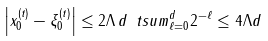Convert formula to latex. <formula><loc_0><loc_0><loc_500><loc_500>\left | x _ { 0 } ^ { ( t ) } - \xi _ { 0 } ^ { ( t ) } \right | & \leq 2 \Lambda \, d \, \ t s u m _ { \ell = 0 } ^ { d } 2 ^ { - \ell } \leq 4 \Lambda d</formula> 